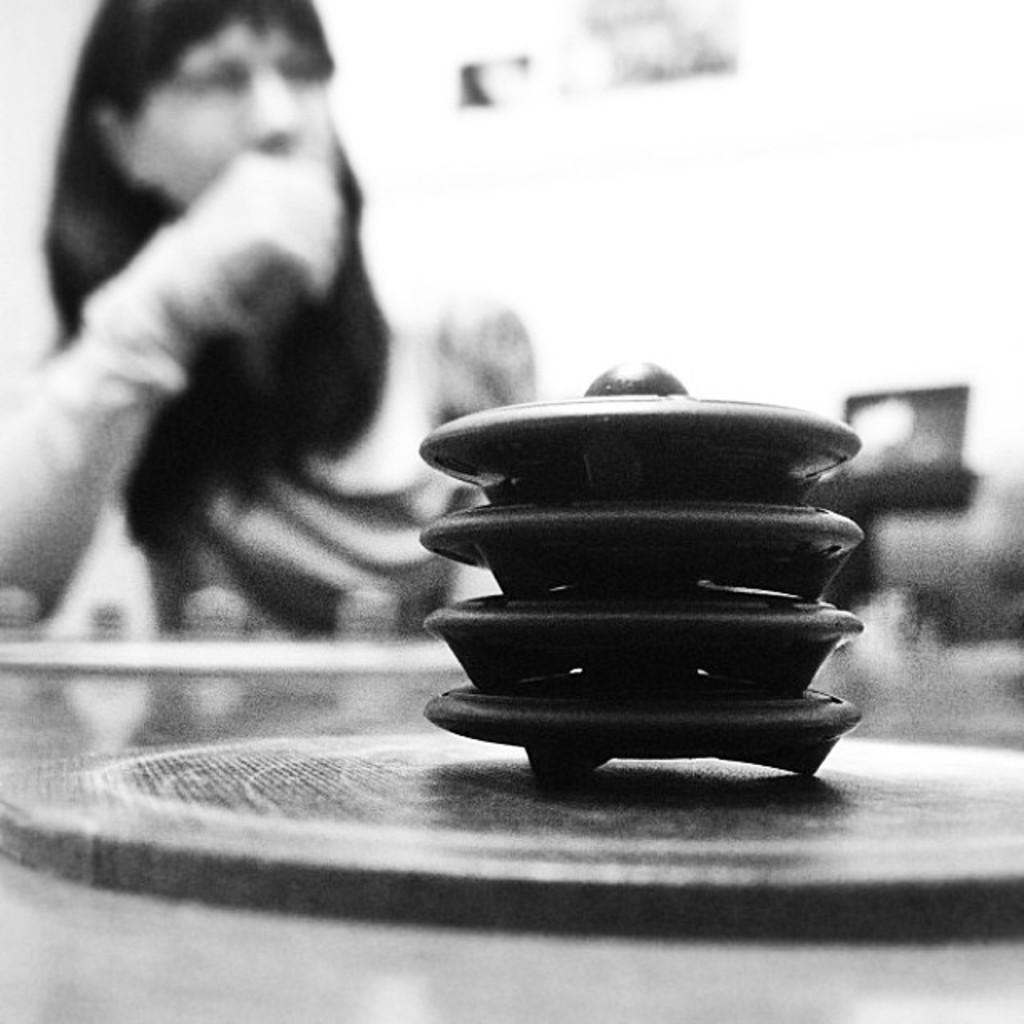What is the color scheme of the image? The image is black and white. What are the kids doing in the image? The kids are stacked one on top of the other in the image. Where is the scene taking place? The scene appears to be on a table. Can you describe the woman in the background of the image? There is a woman sitting in the background of the image. How do the geese react to the angle of the table in the image? There are no geese present in the image, so their reaction to the angle of the table cannot be determined. 